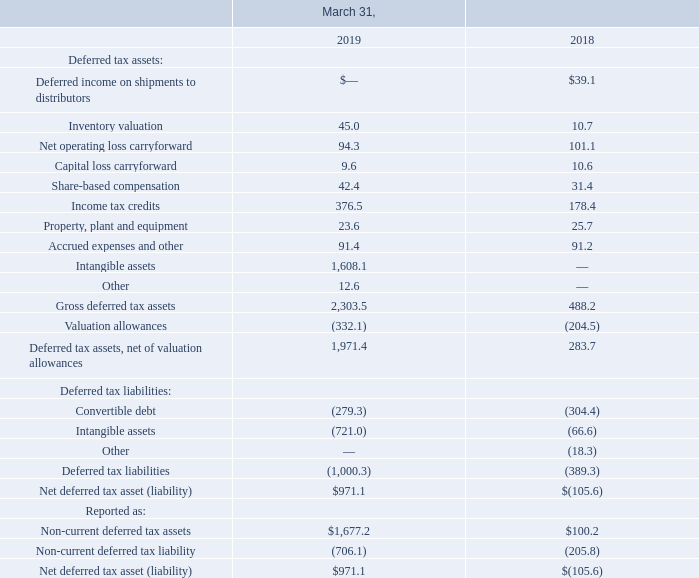The tax effects of temporary differences that give rise to significant portions of the Company's deferred tax assets and deferred tax liabilities are as follows (amounts in millions):
In assessing whether it is more likely than not that deferred tax assets will be realized, the Company considers all available evidence, both positive and negative, including its recent cumulative earnings experience and expectations of future available taxable income of the appropriate character by taxing jurisdiction, tax attribute carryback and carryforward periods available to them for tax reporting purposes, and prudent and feasible tax planning strategies.
Which years does the table provide information for the tax effects of temporary differences that give rise to significant portions of the Company's deferred tax assets and deferred tax liabilities? 2019, 2018. What was the inventory valuation in 2018?
Answer scale should be: million. 10.7. What was the amount of convertible debt in 2019?
Answer scale should be: million. (279.3). What was the change in Deferred tax assets, net of valuation allowances between 2018 and 2019?
Answer scale should be: million. 1,971.4-283.7
Answer: 1687.7. What was the change in Net operating loss carryforward between 2018 and 2019?
Answer scale should be: million. 94.3-101.1
Answer: -6.8. What was the percentage change in the Net deferred tax asset between 2018 and 2019?
Answer scale should be: percent. (971.1-(-105.6))/-105.6
Answer: -1019.6. 